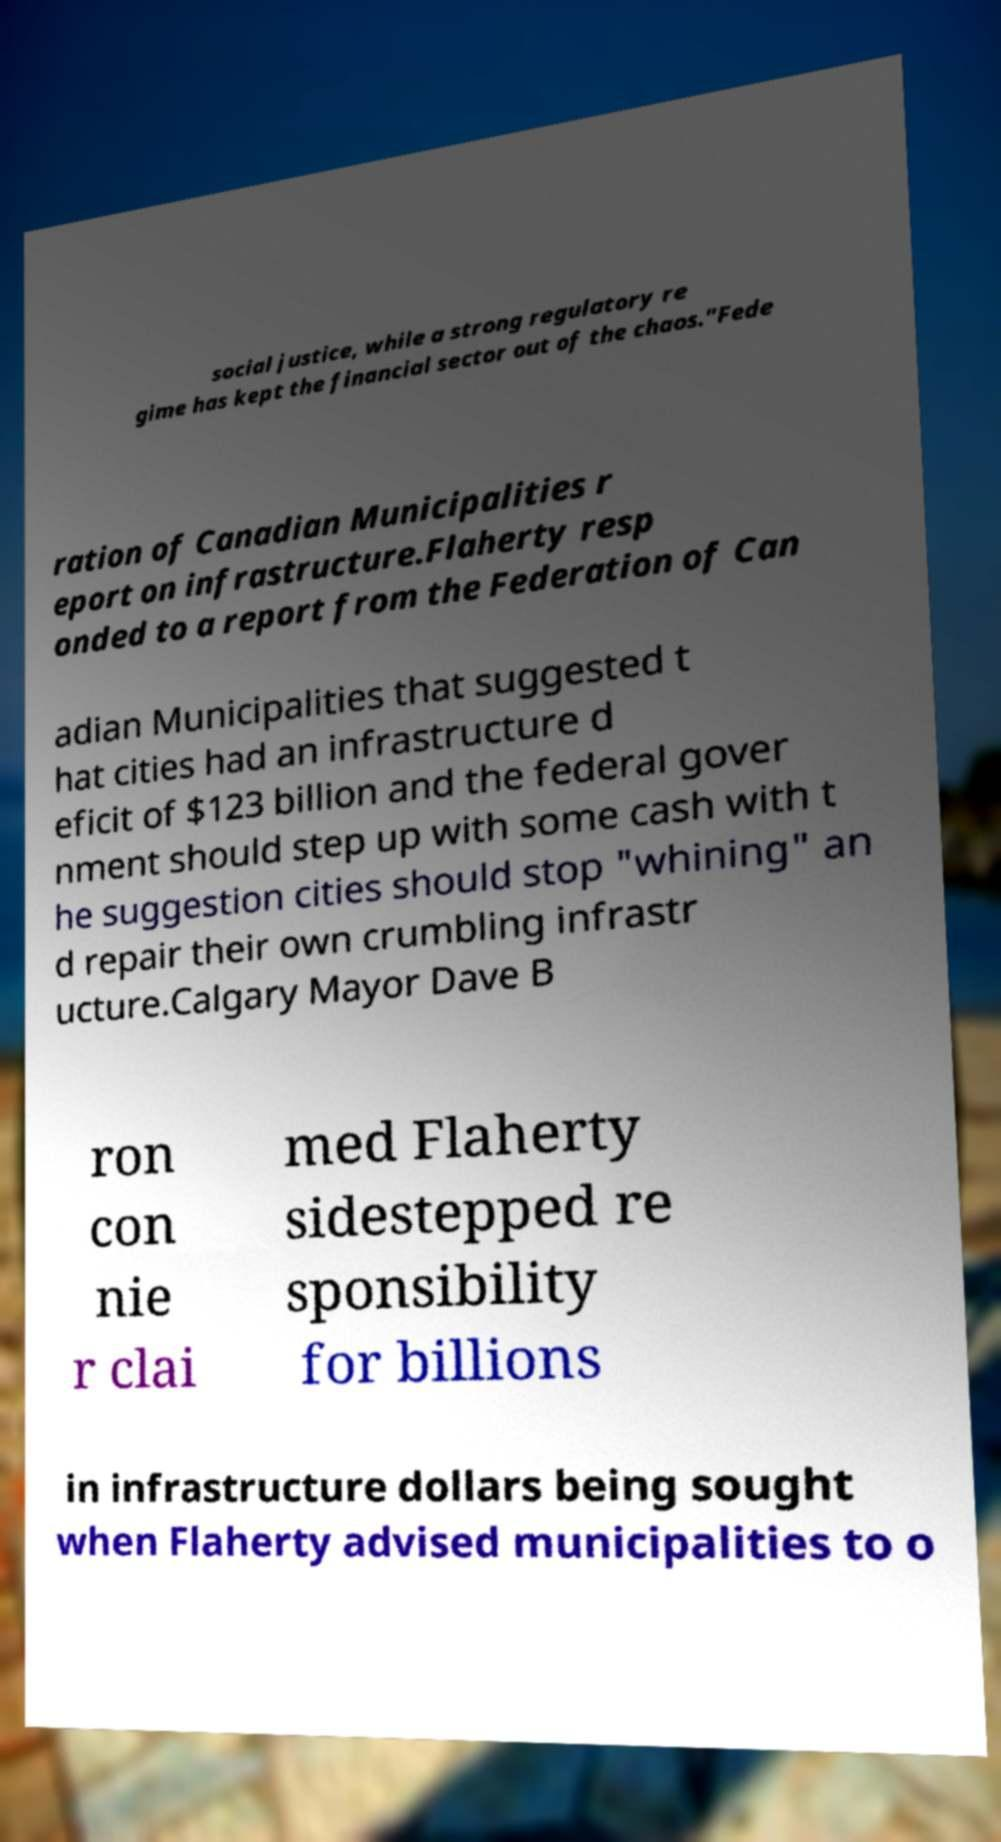Can you accurately transcribe the text from the provided image for me? social justice, while a strong regulatory re gime has kept the financial sector out of the chaos."Fede ration of Canadian Municipalities r eport on infrastructure.Flaherty resp onded to a report from the Federation of Can adian Municipalities that suggested t hat cities had an infrastructure d eficit of $123 billion and the federal gover nment should step up with some cash with t he suggestion cities should stop "whining" an d repair their own crumbling infrastr ucture.Calgary Mayor Dave B ron con nie r clai med Flaherty sidestepped re sponsibility for billions in infrastructure dollars being sought when Flaherty advised municipalities to o 